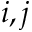<formula> <loc_0><loc_0><loc_500><loc_500>i , j</formula> 